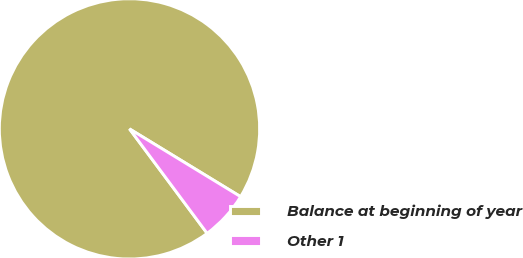<chart> <loc_0><loc_0><loc_500><loc_500><pie_chart><fcel>Balance at beginning of year<fcel>Other 1<nl><fcel>93.89%<fcel>6.11%<nl></chart> 